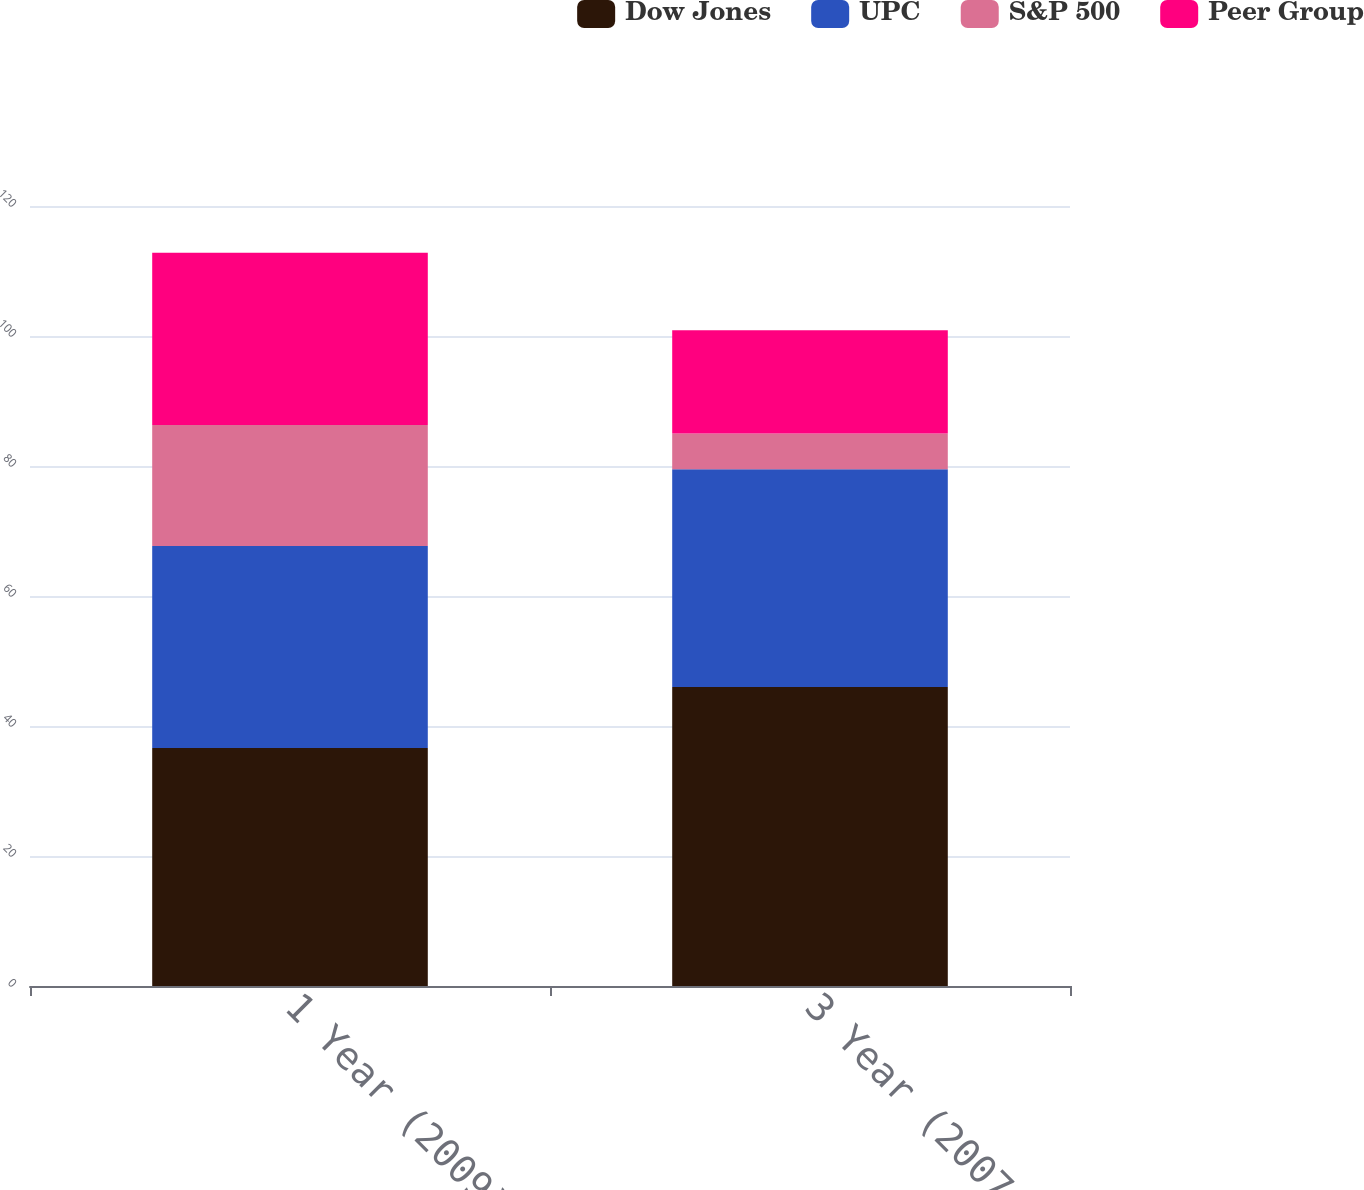<chart> <loc_0><loc_0><loc_500><loc_500><stacked_bar_chart><ecel><fcel>1 Year (2009)<fcel>3 Year (2007-2009)<nl><fcel>Dow Jones<fcel>36.6<fcel>46<nl><fcel>UPC<fcel>31.1<fcel>33.5<nl><fcel>S&P 500<fcel>18.6<fcel>5.5<nl><fcel>Peer Group<fcel>26.5<fcel>15.9<nl></chart> 